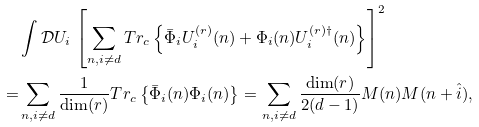<formula> <loc_0><loc_0><loc_500><loc_500>& \int \mathcal { D } U _ { i } \, \left [ \sum _ { n , i \neq d } T r _ { c } \left \{ \bar { \Phi } _ { i } U _ { i } ^ { ( r ) } ( n ) + \Phi _ { i } ( n ) U _ { i } ^ { ( r ) \dagger } ( n ) \right \} \right ] ^ { 2 } \\ = & \sum _ { n , i \neq d } \frac { 1 } { \text {dim} ( r ) } T r _ { c } \left \{ \bar { \Phi } _ { i } ( n ) \Phi _ { i } ( n ) \right \} = \sum _ { n , i \neq d } \frac { \text {dim} ( r ) } { 2 ( d - 1 ) } M ( n ) M ( n + \hat { i } ) ,</formula> 